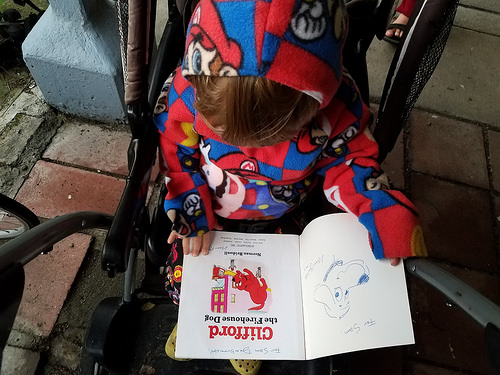<image>
Is there a book under the girl? No. The book is not positioned under the girl. The vertical relationship between these objects is different. 